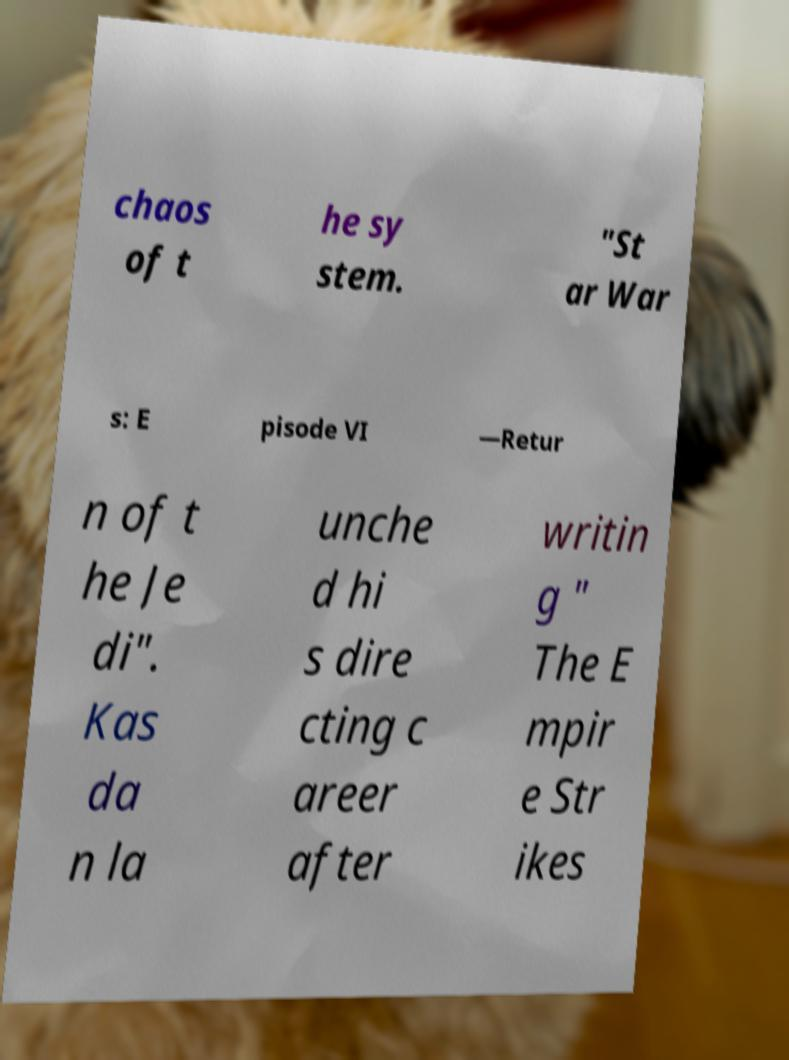Can you read and provide the text displayed in the image?This photo seems to have some interesting text. Can you extract and type it out for me? chaos of t he sy stem. "St ar War s: E pisode VI —Retur n of t he Je di". Kas da n la unche d hi s dire cting c areer after writin g " The E mpir e Str ikes 